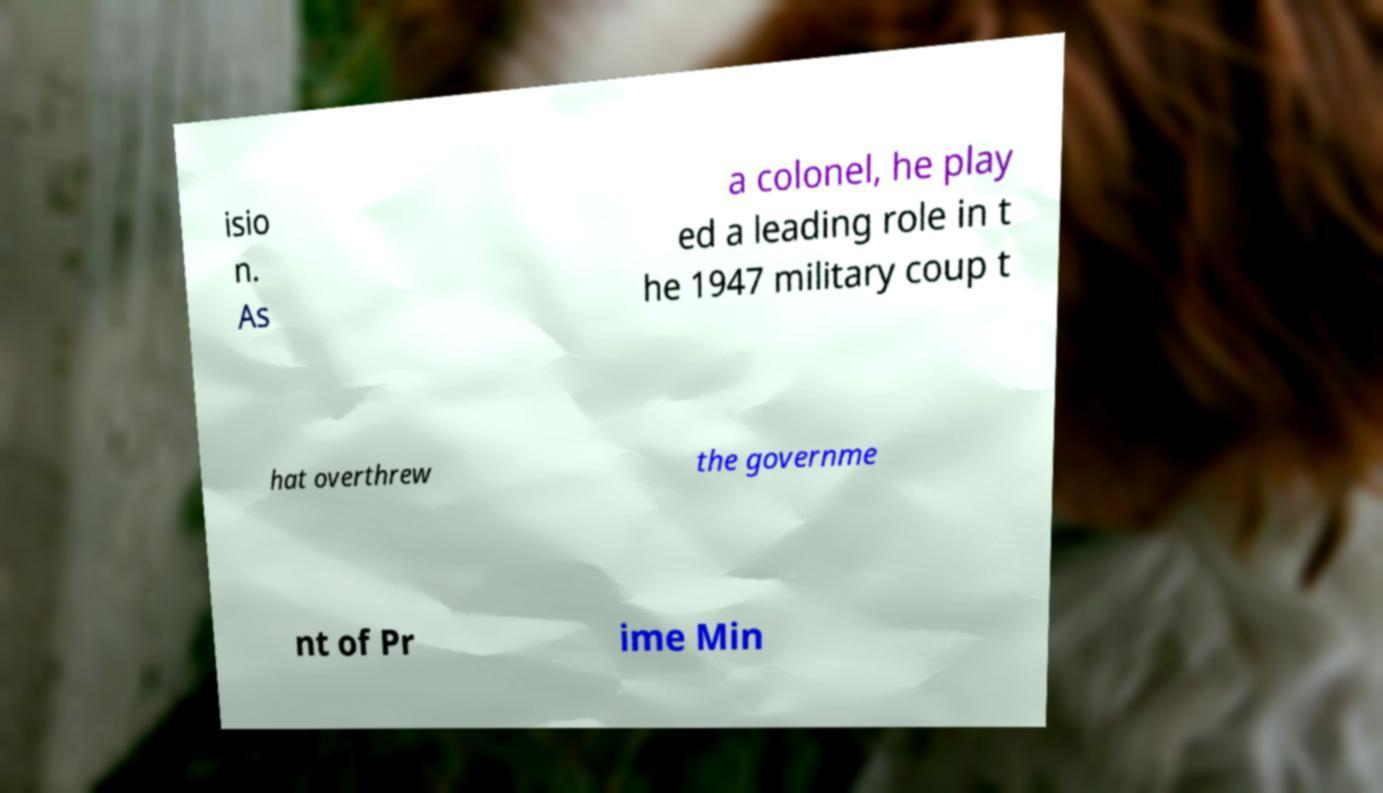What messages or text are displayed in this image? I need them in a readable, typed format. isio n. As a colonel, he play ed a leading role in t he 1947 military coup t hat overthrew the governme nt of Pr ime Min 